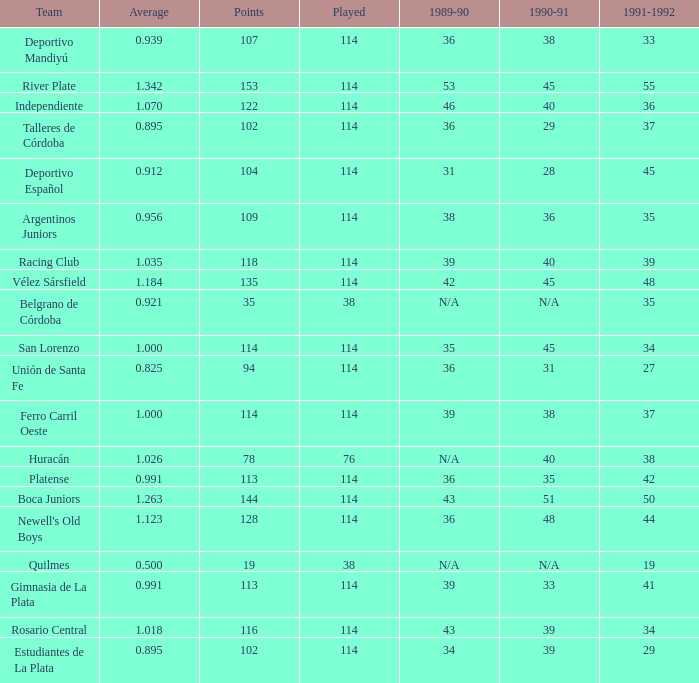How much Average has a 1989-90 of 36, and a Team of talleres de córdoba, and a Played smaller than 114? 0.0. 